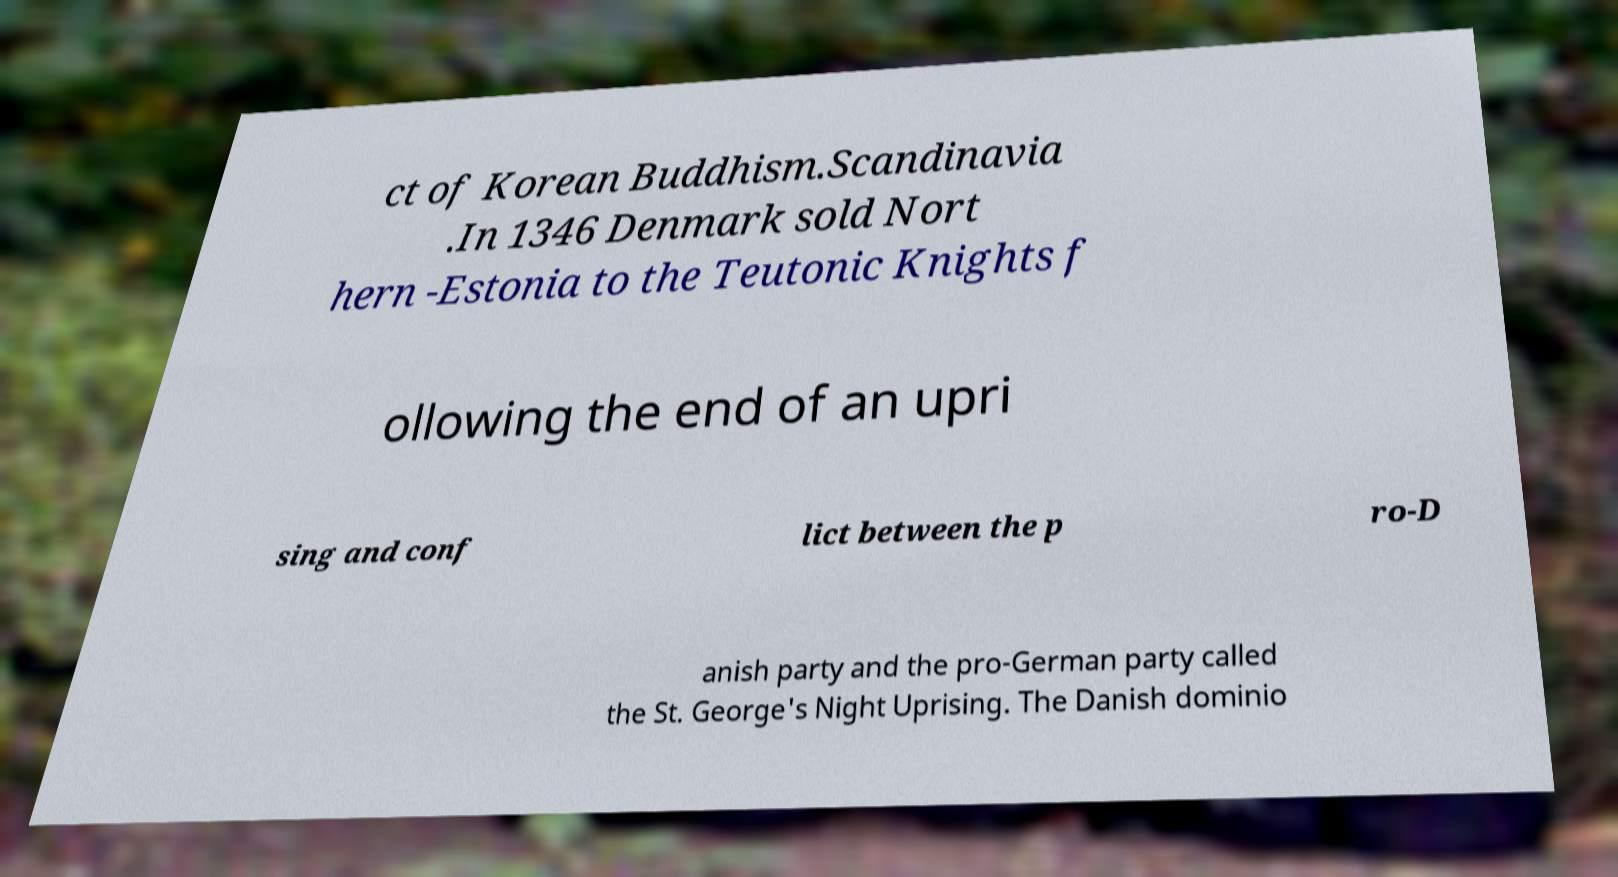I need the written content from this picture converted into text. Can you do that? ct of Korean Buddhism.Scandinavia .In 1346 Denmark sold Nort hern -Estonia to the Teutonic Knights f ollowing the end of an upri sing and conf lict between the p ro-D anish party and the pro-German party called the St. George's Night Uprising. The Danish dominio 